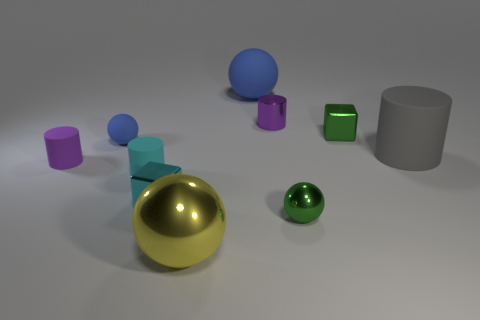There is a thing that is in front of the small cyan cube and on the right side of the purple metallic object; what color is it?
Provide a short and direct response. Green. Is the number of big rubber cylinders that are behind the large gray rubber cylinder less than the number of small cubes that are right of the green sphere?
Offer a very short reply. Yes. How many big blue rubber objects are the same shape as the big gray rubber thing?
Offer a very short reply. 0. What size is the green thing that is the same material as the green cube?
Your answer should be compact. Small. There is a large rubber object that is behind the small purple thing right of the large yellow ball; what color is it?
Your answer should be very brief. Blue. There is a big gray thing; does it have the same shape as the blue rubber object behind the metal cylinder?
Offer a terse response. No. What number of green cubes are the same size as the gray matte cylinder?
Offer a very short reply. 0. What material is the other purple object that is the same shape as the tiny purple matte object?
Your response must be concise. Metal. There is a metallic block that is to the right of the small purple metallic cylinder; does it have the same color as the small sphere in front of the cyan matte cylinder?
Provide a succinct answer. Yes. What is the shape of the purple object left of the purple metal object?
Ensure brevity in your answer.  Cylinder. 